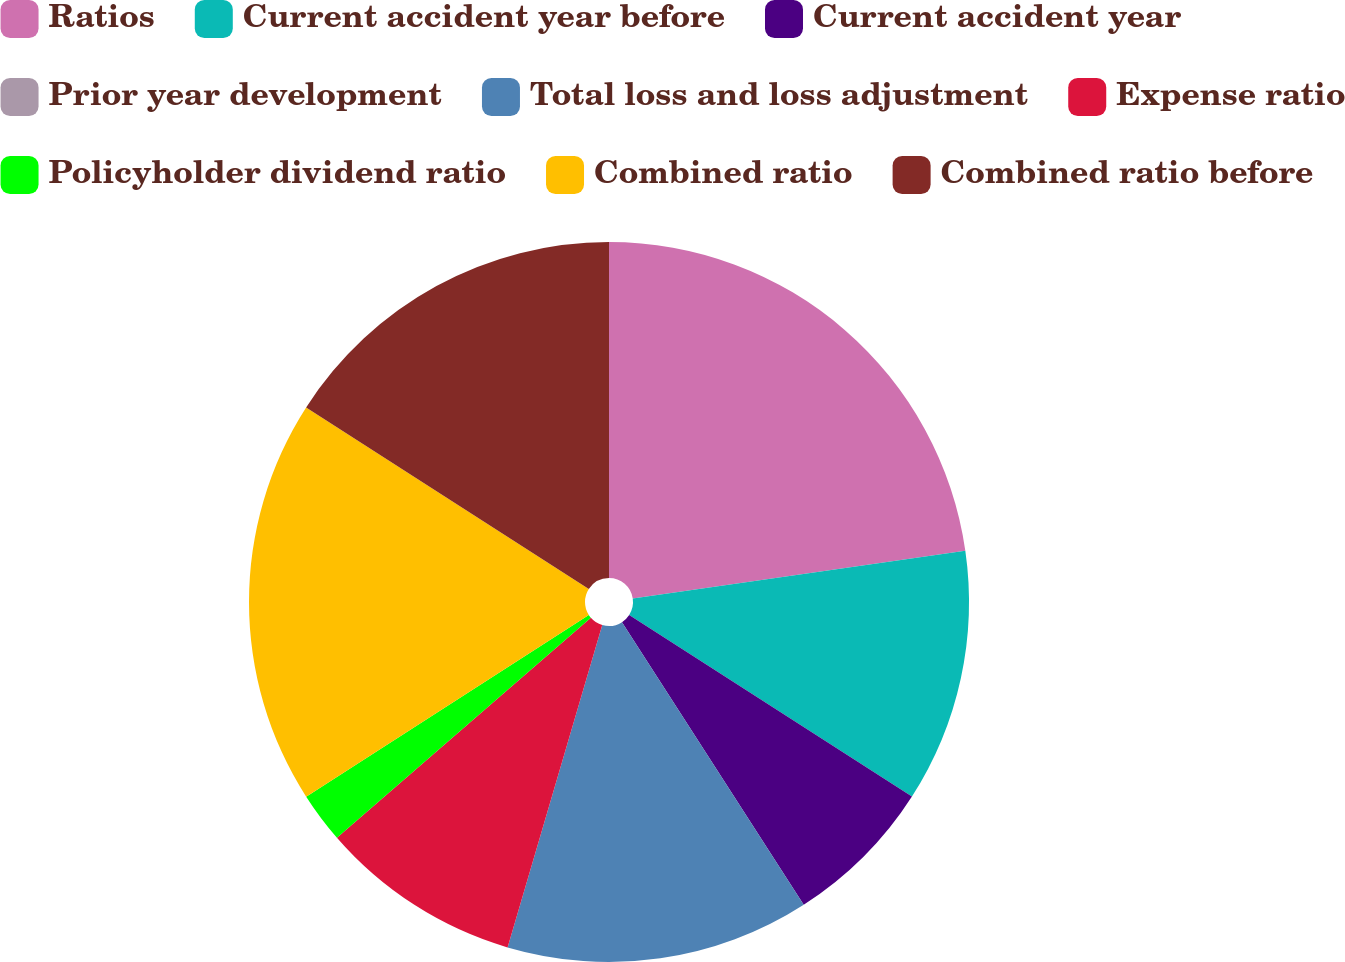Convert chart. <chart><loc_0><loc_0><loc_500><loc_500><pie_chart><fcel>Ratios<fcel>Current accident year before<fcel>Current accident year<fcel>Prior year development<fcel>Total loss and loss adjustment<fcel>Expense ratio<fcel>Policyholder dividend ratio<fcel>Combined ratio<fcel>Combined ratio before<nl><fcel>22.72%<fcel>11.36%<fcel>6.82%<fcel>0.0%<fcel>13.64%<fcel>9.09%<fcel>2.27%<fcel>18.18%<fcel>15.91%<nl></chart> 